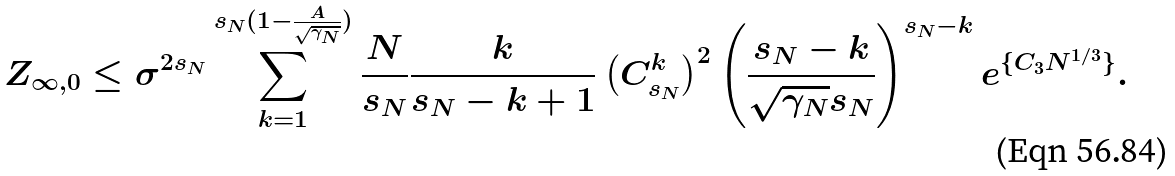Convert formula to latex. <formula><loc_0><loc_0><loc_500><loc_500>Z _ { \infty , 0 } \leq \sigma ^ { 2 s _ { N } } \sum _ { k = 1 } ^ { s _ { N } ( 1 - \frac { A } { \sqrt { \gamma _ { N } } } ) } \frac { N } { s _ { N } } \frac { k } { s _ { N } - k + 1 } \left ( C _ { s _ { N } } ^ { k } \right ) ^ { 2 } \left ( \frac { s _ { N } - k } { \sqrt { \gamma _ { N } } s _ { N } } \right ) ^ { s _ { N } - k } e ^ { \{ C _ { 3 } N ^ { 1 / 3 } \} } .</formula> 